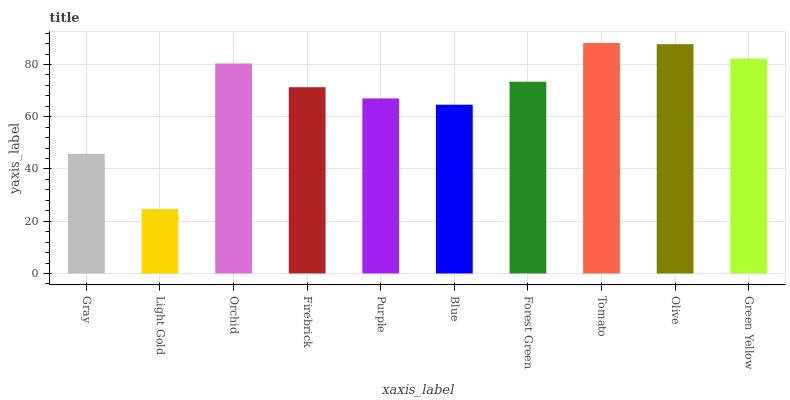Is Orchid the minimum?
Answer yes or no. No. Is Orchid the maximum?
Answer yes or no. No. Is Orchid greater than Light Gold?
Answer yes or no. Yes. Is Light Gold less than Orchid?
Answer yes or no. Yes. Is Light Gold greater than Orchid?
Answer yes or no. No. Is Orchid less than Light Gold?
Answer yes or no. No. Is Forest Green the high median?
Answer yes or no. Yes. Is Firebrick the low median?
Answer yes or no. Yes. Is Light Gold the high median?
Answer yes or no. No. Is Forest Green the low median?
Answer yes or no. No. 